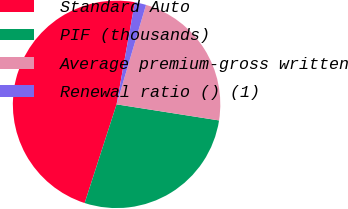Convert chart to OTSL. <chart><loc_0><loc_0><loc_500><loc_500><pie_chart><fcel>Standard Auto<fcel>PIF (thousands)<fcel>Average premium-gross written<fcel>Renewal ratio () (1)<nl><fcel>47.84%<fcel>27.5%<fcel>22.9%<fcel>1.76%<nl></chart> 